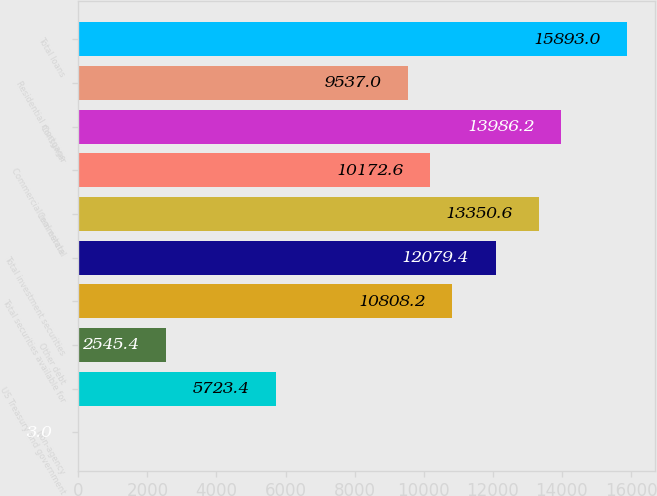<chart> <loc_0><loc_0><loc_500><loc_500><bar_chart><fcel>Non-agency<fcel>US Treasury and government<fcel>Other debt<fcel>Total securities available for<fcel>Total investment securities<fcel>Commercial<fcel>Commercial real estate<fcel>Consumer<fcel>Residential mortgage<fcel>Total loans<nl><fcel>3<fcel>5723.4<fcel>2545.4<fcel>10808.2<fcel>12079.4<fcel>13350.6<fcel>10172.6<fcel>13986.2<fcel>9537<fcel>15893<nl></chart> 